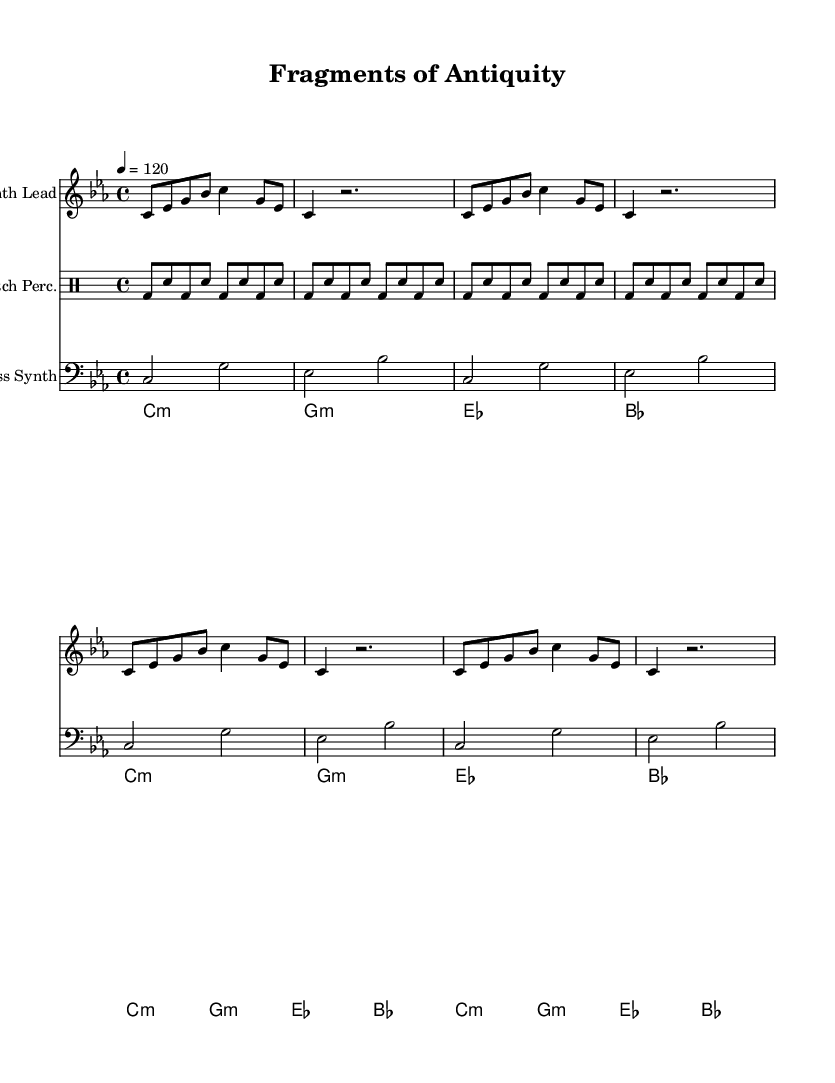What is the key signature of this music? The key signature is C minor, indicated by three flat symbols which correspond to the notes E♭, A♭, and B♭.
Answer: C minor What is the time signature of this music? The time signature is 4/4, which means there are four beats in each measure and the quarter note receives one beat.
Answer: 4/4 What is the tempo marking of this piece? The tempo marking is 120 beats per minute, denoted by the instruction "4 = 120", indicating the speed at which the piece should be played.
Answer: 120 How many repeats does the synth lead section have? The synth lead section contains three repeats of the same musical phrase, indicated by the repeat symbol "repeat unfold 3" in the notation.
Answer: 3 What type of percussion is used in this composition? The percussion used is classified as "Glitch Perc.", which is a type of percussion typical in electronic music that often involves irregular or unexpected sounds.
Answer: Glitch Perc What harmonic progression is used for the ambient pad section? The harmonic progression for the ambient pad section is C minor, G minor, E♭, B♭, as indicated by the chord symbols in the sheet music.
Answer: C minor, G minor, E♭, B♭ How does the bass synth's rhythmic pattern compare to the synth lead? The bass synth follows a more straightforward rhythmic pattern without the syncopation seen in the synth lead, providing a foundation for the composition.
Answer: Straightforward 